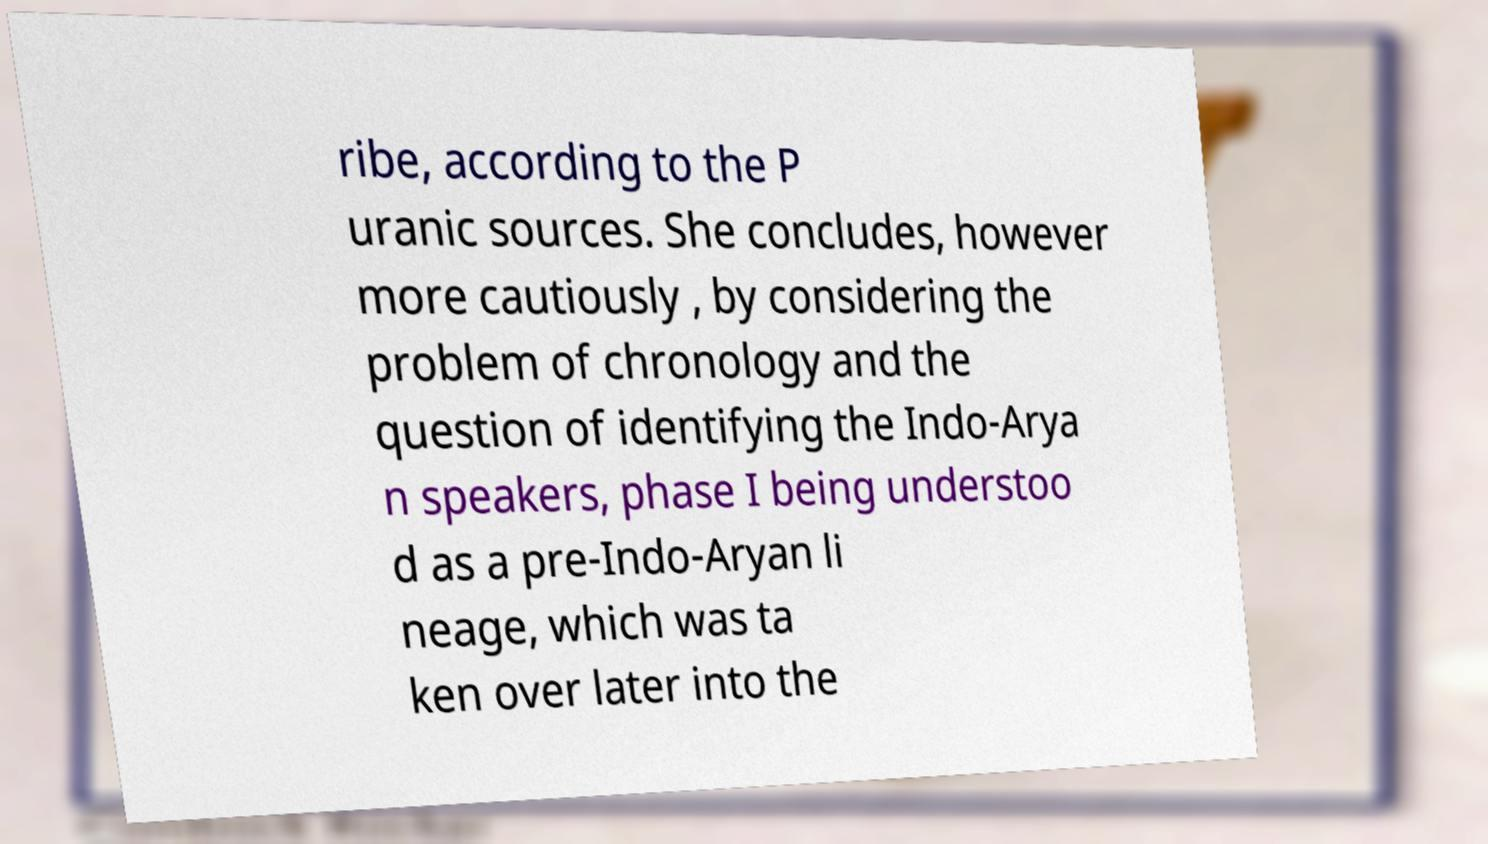For documentation purposes, I need the text within this image transcribed. Could you provide that? ribe, according to the P uranic sources. She concludes, however more cautiously , by considering the problem of chronology and the question of identifying the Indo-Arya n speakers, phase I being understoo d as a pre-Indo-Aryan li neage, which was ta ken over later into the 